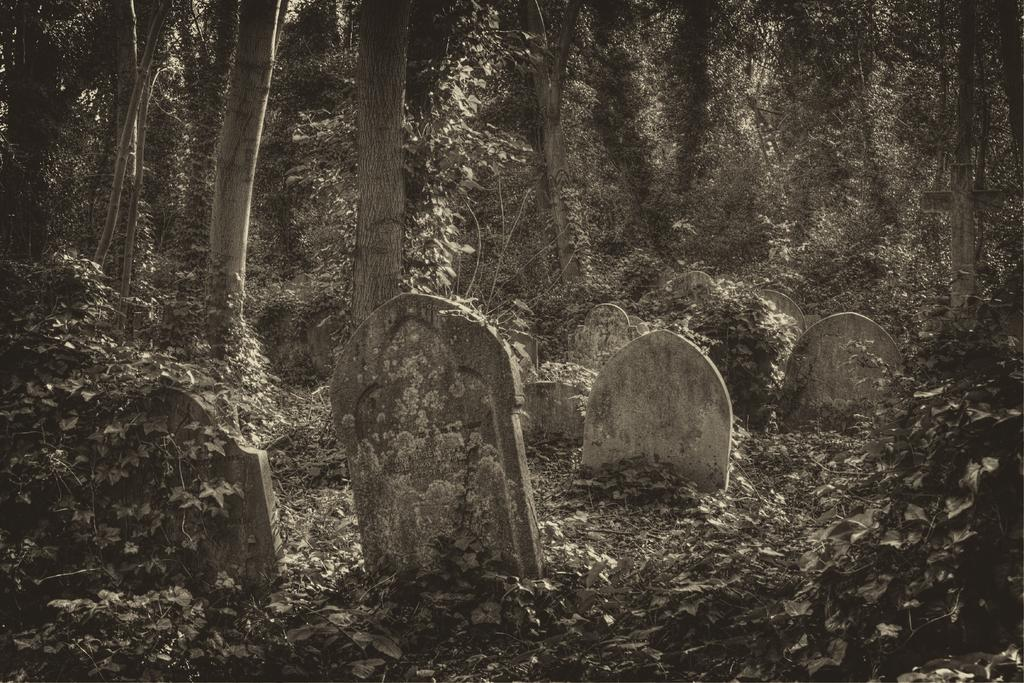What type of objects can be seen in the image? There are grave stones in the image. What else is present on the ground in the image? There are dry leaves in the image. What can be seen in the background of the image? There are trees in the background of the image. What is the color scheme of the image? The image is black and white. Who is the owner of the clam in the image? There is no clam present in the image. What type of cushion can be seen on the grave stones in the image? There is no cushion present on the grave stones in the image. 